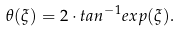<formula> <loc_0><loc_0><loc_500><loc_500>\theta ( \xi ) = 2 \cdot t a n ^ { - 1 } e x p ( \xi ) .</formula> 